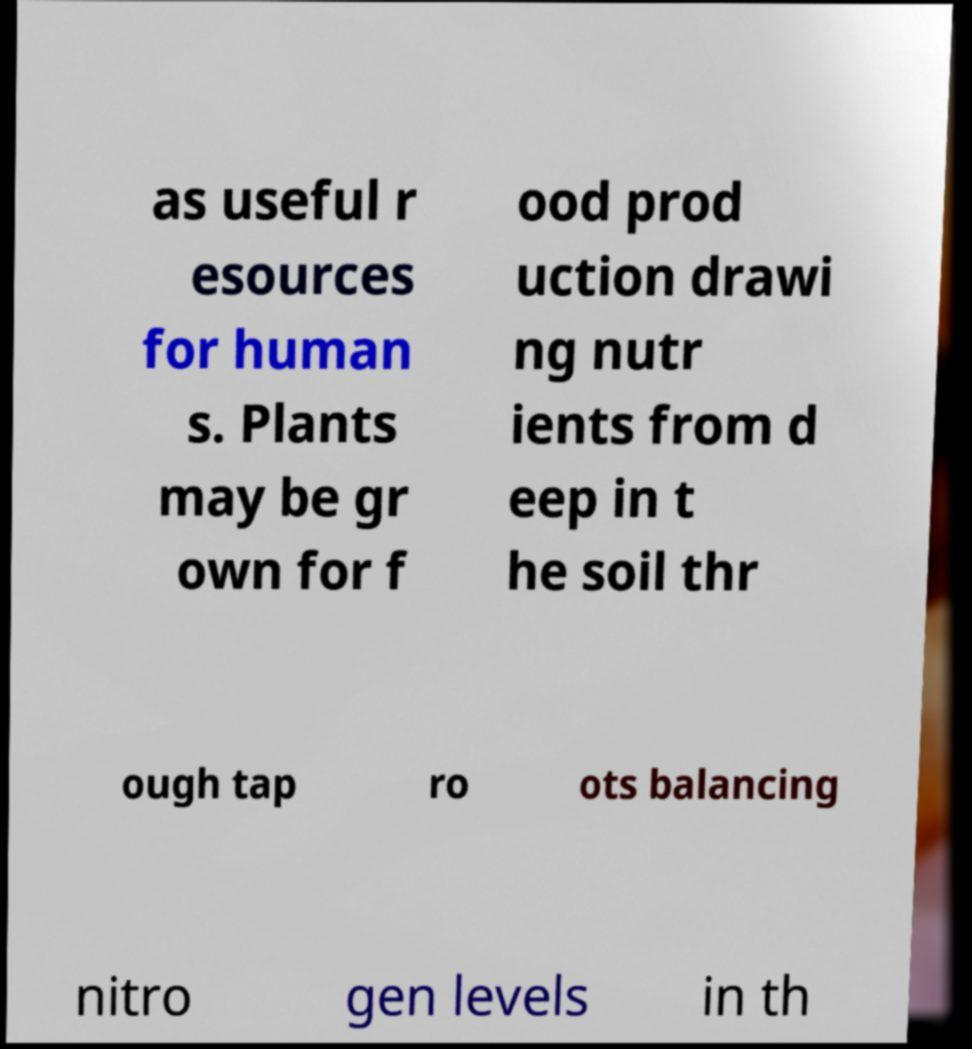Please read and relay the text visible in this image. What does it say? as useful r esources for human s. Plants may be gr own for f ood prod uction drawi ng nutr ients from d eep in t he soil thr ough tap ro ots balancing nitro gen levels in th 